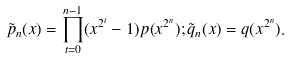Convert formula to latex. <formula><loc_0><loc_0><loc_500><loc_500>\tilde { p } _ { n } ( x ) = \prod _ { t = 0 } ^ { n - 1 } ( x ^ { 2 ^ { t } } - 1 ) p ( x ^ { 2 ^ { n } } ) ; \tilde { q } _ { n } ( x ) = q ( x ^ { 2 ^ { n } } ) .</formula> 